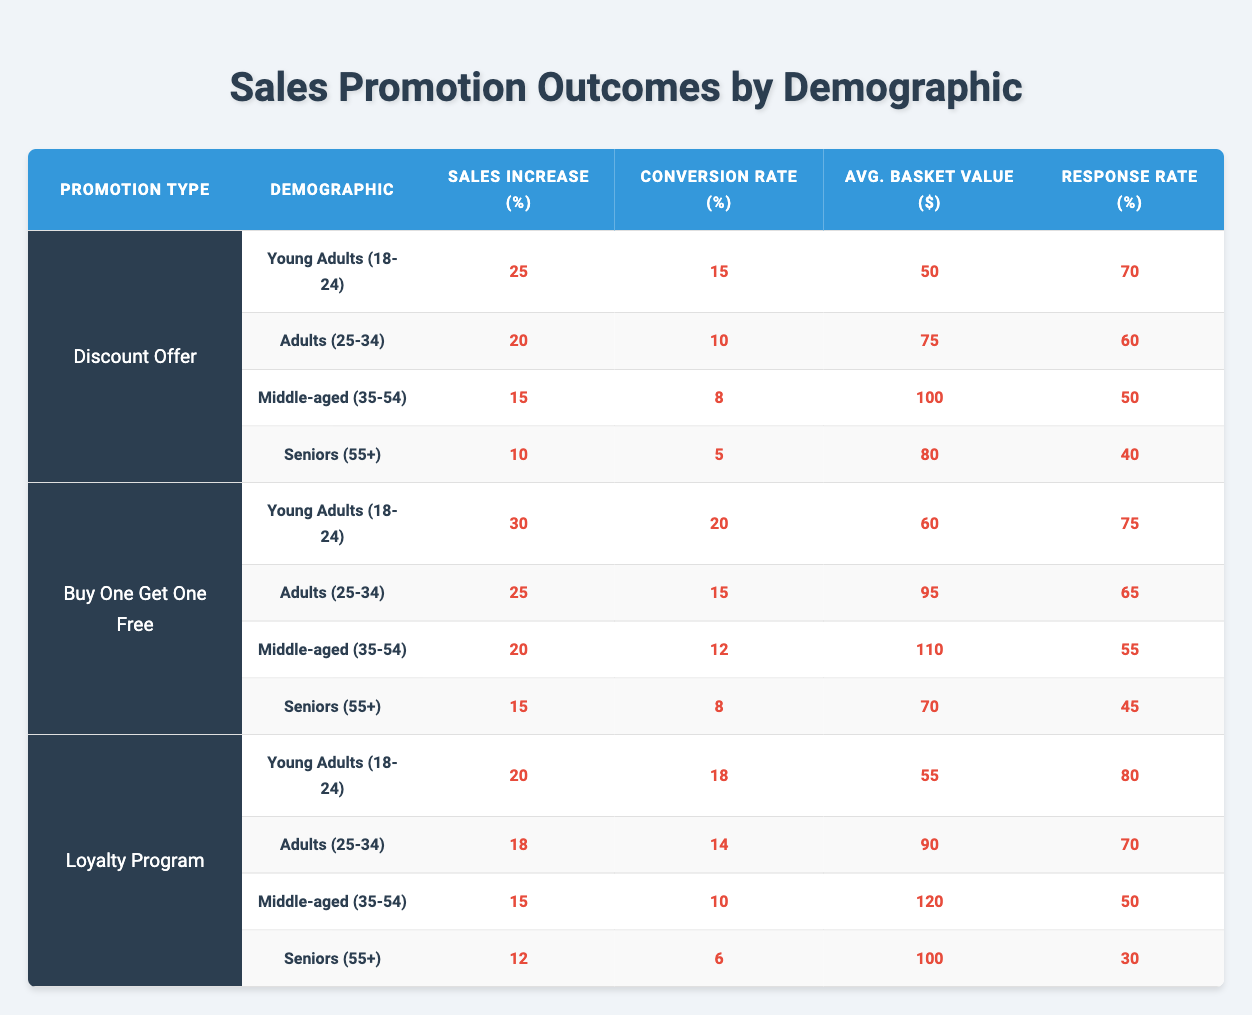What is the highest sales increase percentage from a discount offer among the demographic audiences? Looking at the "Sales Increase (%)" column under the "Discount Offer" promotion type, the highest value is 25 for the demographic "Young Adults (18-24)."
Answer: 25 Which demographic has the lowest conversion rate for Buy One Get One Free promotions? The "Conversion Rate (%)" for "Seniors (55+)" under the "Buy One Get One Free" promotion is the lowest at 8.
Answer: 8 What is the average average basket value for adults (25-34) across all promotion types? The average basket values for adults (25-34) are 75 (Discount Offer), 95 (Buy One Get One Free), and 90 (Loyalty Program). Sum them up: 75 + 95 + 90 = 260, then divide by the 3 promotions to get 260 / 3 = approximately 86.67.
Answer: Approximately 86.67 Did the "Young Adults (18-24)" demographic have a higher response rate for the Loyalty Program compared to the "Seniors (55+)"? Yes, the response rate for "Young Adults (18-24)" in the Loyalty Program is 80, which is higher than the 30 for "Seniors (55+)."
Answer: Yes What is the total sales increase percentage for "Middle-aged (35-54)" across all promotions? The sales increase percentages for "Middle-aged (35-54)" are 15 (Discount Offer), 20 (Buy One Get One Free), and 15 (Loyalty Program). Summing these gives 15 + 20 + 15 = 50.
Answer: 50 